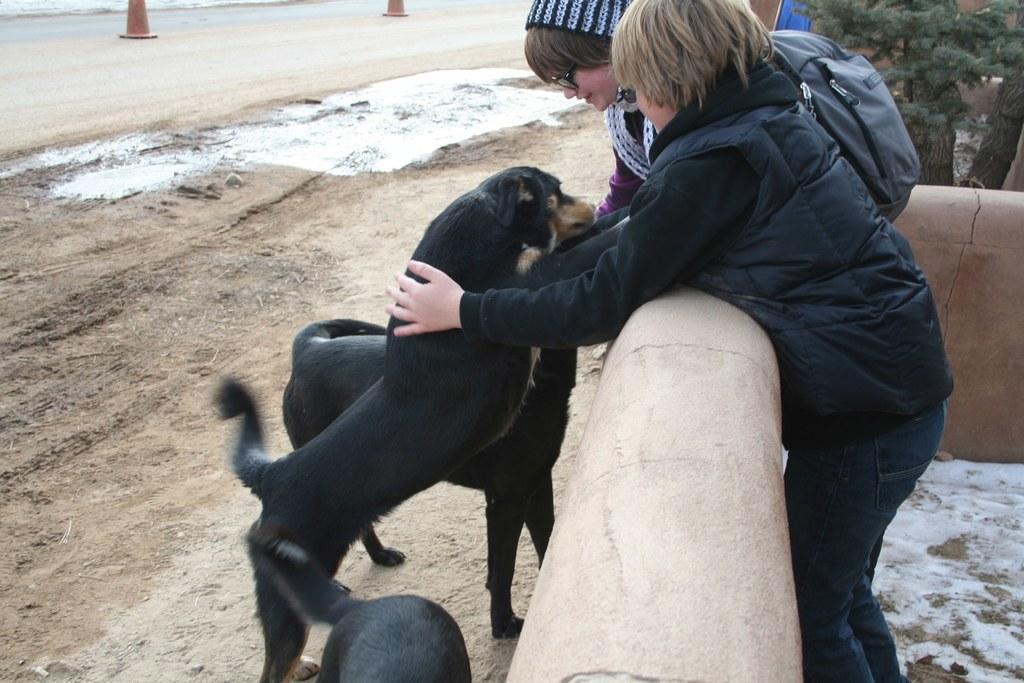In one or two sentences, can you explain what this image depicts? In this image there are two persons standing and they are holding dogs and one person is wearing a bag. At the bottom there is another dog and there is a wall, in the background there is sand, mud and barricades and a walkway. And on the right side there are some trees. 